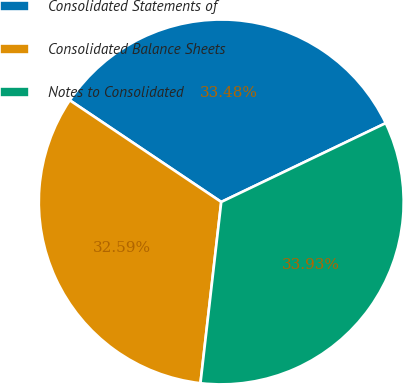Convert chart. <chart><loc_0><loc_0><loc_500><loc_500><pie_chart><fcel>Consolidated Statements of<fcel>Consolidated Balance Sheets<fcel>Notes to Consolidated<nl><fcel>33.48%<fcel>32.59%<fcel>33.93%<nl></chart> 